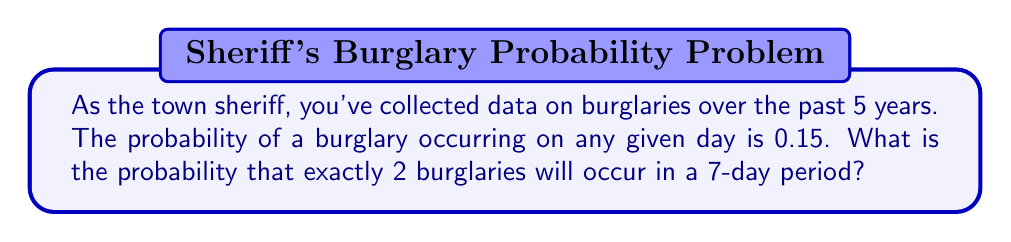Provide a solution to this math problem. To solve this problem, we'll use the binomial probability formula since we're dealing with a fixed number of independent trials (7 days) with two possible outcomes (burglary occurs or doesn't occur) and a constant probability of success.

The binomial probability formula is:

$$P(X = k) = \binom{n}{k} p^k (1-p)^{n-k}$$

Where:
$n$ = number of trials (7 days)
$k$ = number of successes (2 burglaries)
$p$ = probability of success on each trial (0.15)

Step 1: Calculate the binomial coefficient $\binom{n}{k}$
$$\binom{7}{2} = \frac{7!}{2!(7-2)!} = \frac{7 \cdot 6}{2 \cdot 1} = 21$$

Step 2: Calculate $p^k$
$$0.15^2 = 0.0225$$

Step 3: Calculate $(1-p)^{n-k}$
$$(1-0.15)^{7-2} = 0.85^5 \approx 0.4437$$

Step 4: Multiply the results from steps 1, 2, and 3
$$21 \cdot 0.0225 \cdot 0.4437 \approx 0.2097$$

Therefore, the probability of exactly 2 burglaries occurring in a 7-day period is approximately 0.2097 or 20.97%.
Answer: $0.2097$ or $20.97\%$ 